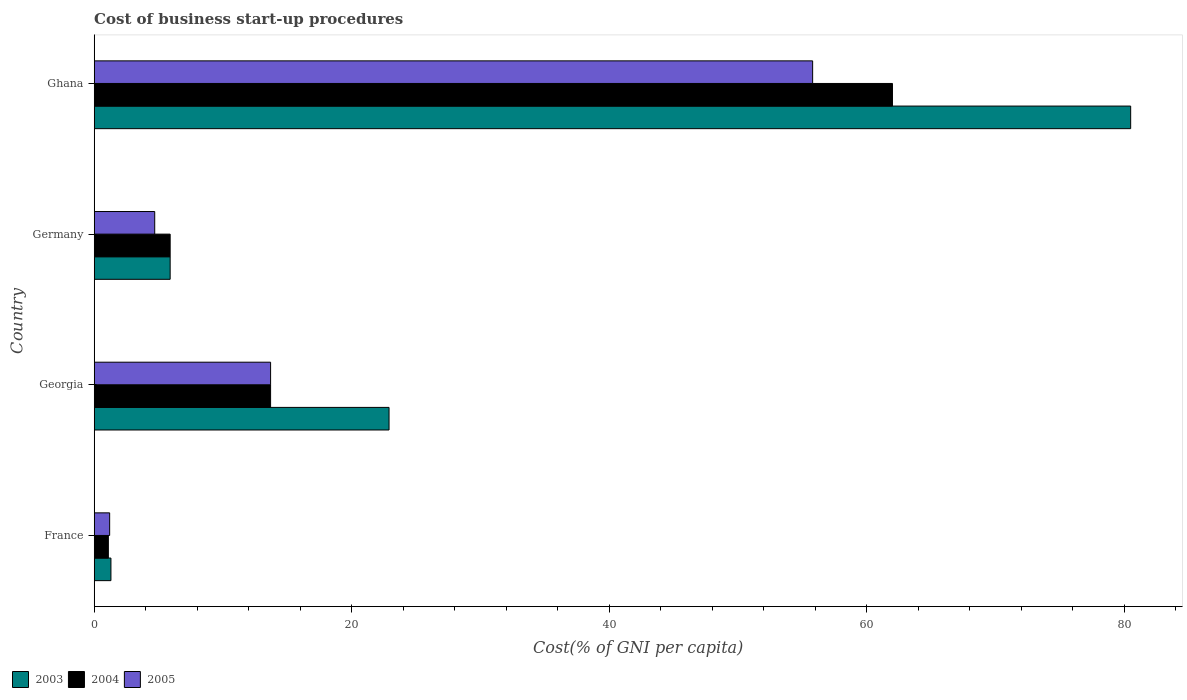How many different coloured bars are there?
Provide a short and direct response. 3. How many bars are there on the 4th tick from the bottom?
Keep it short and to the point. 3. What is the cost of business start-up procedures in 2004 in Ghana?
Ensure brevity in your answer.  62. Across all countries, what is the minimum cost of business start-up procedures in 2004?
Your answer should be very brief. 1.1. In which country was the cost of business start-up procedures in 2003 minimum?
Your answer should be compact. France. What is the total cost of business start-up procedures in 2004 in the graph?
Keep it short and to the point. 82.7. What is the difference between the cost of business start-up procedures in 2003 in Germany and that in Ghana?
Offer a very short reply. -74.6. What is the difference between the cost of business start-up procedures in 2003 in Ghana and the cost of business start-up procedures in 2004 in Georgia?
Offer a very short reply. 66.8. What is the average cost of business start-up procedures in 2004 per country?
Your answer should be compact. 20.68. What is the difference between the cost of business start-up procedures in 2003 and cost of business start-up procedures in 2004 in France?
Your answer should be very brief. 0.2. What is the ratio of the cost of business start-up procedures in 2005 in Germany to that in Ghana?
Ensure brevity in your answer.  0.08. Is the cost of business start-up procedures in 2003 in Georgia less than that in Ghana?
Your answer should be very brief. Yes. Is the difference between the cost of business start-up procedures in 2003 in Georgia and Germany greater than the difference between the cost of business start-up procedures in 2004 in Georgia and Germany?
Offer a very short reply. Yes. What is the difference between the highest and the second highest cost of business start-up procedures in 2003?
Your response must be concise. 57.6. What is the difference between the highest and the lowest cost of business start-up procedures in 2004?
Provide a short and direct response. 60.9. Is the sum of the cost of business start-up procedures in 2005 in France and Georgia greater than the maximum cost of business start-up procedures in 2003 across all countries?
Offer a terse response. No. What does the 3rd bar from the top in Ghana represents?
Your response must be concise. 2003. What does the 2nd bar from the bottom in France represents?
Your response must be concise. 2004. How many bars are there?
Offer a very short reply. 12. Are all the bars in the graph horizontal?
Ensure brevity in your answer.  Yes. Are the values on the major ticks of X-axis written in scientific E-notation?
Keep it short and to the point. No. Where does the legend appear in the graph?
Provide a short and direct response. Bottom left. What is the title of the graph?
Your answer should be very brief. Cost of business start-up procedures. Does "1981" appear as one of the legend labels in the graph?
Provide a short and direct response. No. What is the label or title of the X-axis?
Ensure brevity in your answer.  Cost(% of GNI per capita). What is the Cost(% of GNI per capita) of 2004 in France?
Keep it short and to the point. 1.1. What is the Cost(% of GNI per capita) of 2003 in Georgia?
Offer a terse response. 22.9. What is the Cost(% of GNI per capita) of 2005 in Georgia?
Keep it short and to the point. 13.7. What is the Cost(% of GNI per capita) of 2003 in Germany?
Ensure brevity in your answer.  5.9. What is the Cost(% of GNI per capita) in 2005 in Germany?
Provide a succinct answer. 4.7. What is the Cost(% of GNI per capita) of 2003 in Ghana?
Give a very brief answer. 80.5. What is the Cost(% of GNI per capita) of 2005 in Ghana?
Keep it short and to the point. 55.8. Across all countries, what is the maximum Cost(% of GNI per capita) of 2003?
Your answer should be very brief. 80.5. Across all countries, what is the maximum Cost(% of GNI per capita) in 2005?
Provide a succinct answer. 55.8. Across all countries, what is the minimum Cost(% of GNI per capita) of 2003?
Your answer should be very brief. 1.3. Across all countries, what is the minimum Cost(% of GNI per capita) in 2004?
Make the answer very short. 1.1. Across all countries, what is the minimum Cost(% of GNI per capita) of 2005?
Keep it short and to the point. 1.2. What is the total Cost(% of GNI per capita) of 2003 in the graph?
Provide a succinct answer. 110.6. What is the total Cost(% of GNI per capita) of 2004 in the graph?
Provide a succinct answer. 82.7. What is the total Cost(% of GNI per capita) of 2005 in the graph?
Your response must be concise. 75.4. What is the difference between the Cost(% of GNI per capita) in 2003 in France and that in Georgia?
Your answer should be very brief. -21.6. What is the difference between the Cost(% of GNI per capita) of 2004 in France and that in Georgia?
Keep it short and to the point. -12.6. What is the difference between the Cost(% of GNI per capita) of 2005 in France and that in Germany?
Offer a very short reply. -3.5. What is the difference between the Cost(% of GNI per capita) in 2003 in France and that in Ghana?
Provide a short and direct response. -79.2. What is the difference between the Cost(% of GNI per capita) in 2004 in France and that in Ghana?
Keep it short and to the point. -60.9. What is the difference between the Cost(% of GNI per capita) of 2005 in France and that in Ghana?
Provide a short and direct response. -54.6. What is the difference between the Cost(% of GNI per capita) in 2003 in Georgia and that in Germany?
Offer a terse response. 17. What is the difference between the Cost(% of GNI per capita) of 2005 in Georgia and that in Germany?
Give a very brief answer. 9. What is the difference between the Cost(% of GNI per capita) in 2003 in Georgia and that in Ghana?
Make the answer very short. -57.6. What is the difference between the Cost(% of GNI per capita) of 2004 in Georgia and that in Ghana?
Ensure brevity in your answer.  -48.3. What is the difference between the Cost(% of GNI per capita) in 2005 in Georgia and that in Ghana?
Offer a very short reply. -42.1. What is the difference between the Cost(% of GNI per capita) of 2003 in Germany and that in Ghana?
Your answer should be compact. -74.6. What is the difference between the Cost(% of GNI per capita) in 2004 in Germany and that in Ghana?
Offer a terse response. -56.1. What is the difference between the Cost(% of GNI per capita) of 2005 in Germany and that in Ghana?
Make the answer very short. -51.1. What is the difference between the Cost(% of GNI per capita) in 2003 in France and the Cost(% of GNI per capita) in 2004 in Georgia?
Ensure brevity in your answer.  -12.4. What is the difference between the Cost(% of GNI per capita) of 2004 in France and the Cost(% of GNI per capita) of 2005 in Georgia?
Ensure brevity in your answer.  -12.6. What is the difference between the Cost(% of GNI per capita) of 2003 in France and the Cost(% of GNI per capita) of 2004 in Germany?
Make the answer very short. -4.6. What is the difference between the Cost(% of GNI per capita) of 2004 in France and the Cost(% of GNI per capita) of 2005 in Germany?
Your answer should be compact. -3.6. What is the difference between the Cost(% of GNI per capita) of 2003 in France and the Cost(% of GNI per capita) of 2004 in Ghana?
Your response must be concise. -60.7. What is the difference between the Cost(% of GNI per capita) in 2003 in France and the Cost(% of GNI per capita) in 2005 in Ghana?
Keep it short and to the point. -54.5. What is the difference between the Cost(% of GNI per capita) of 2004 in France and the Cost(% of GNI per capita) of 2005 in Ghana?
Your answer should be compact. -54.7. What is the difference between the Cost(% of GNI per capita) of 2003 in Georgia and the Cost(% of GNI per capita) of 2004 in Germany?
Make the answer very short. 17. What is the difference between the Cost(% of GNI per capita) of 2003 in Georgia and the Cost(% of GNI per capita) of 2005 in Germany?
Make the answer very short. 18.2. What is the difference between the Cost(% of GNI per capita) in 2003 in Georgia and the Cost(% of GNI per capita) in 2004 in Ghana?
Provide a succinct answer. -39.1. What is the difference between the Cost(% of GNI per capita) in 2003 in Georgia and the Cost(% of GNI per capita) in 2005 in Ghana?
Make the answer very short. -32.9. What is the difference between the Cost(% of GNI per capita) in 2004 in Georgia and the Cost(% of GNI per capita) in 2005 in Ghana?
Make the answer very short. -42.1. What is the difference between the Cost(% of GNI per capita) in 2003 in Germany and the Cost(% of GNI per capita) in 2004 in Ghana?
Your answer should be very brief. -56.1. What is the difference between the Cost(% of GNI per capita) of 2003 in Germany and the Cost(% of GNI per capita) of 2005 in Ghana?
Provide a short and direct response. -49.9. What is the difference between the Cost(% of GNI per capita) in 2004 in Germany and the Cost(% of GNI per capita) in 2005 in Ghana?
Your response must be concise. -49.9. What is the average Cost(% of GNI per capita) in 2003 per country?
Ensure brevity in your answer.  27.65. What is the average Cost(% of GNI per capita) in 2004 per country?
Your answer should be very brief. 20.68. What is the average Cost(% of GNI per capita) in 2005 per country?
Provide a short and direct response. 18.85. What is the difference between the Cost(% of GNI per capita) of 2003 and Cost(% of GNI per capita) of 2004 in France?
Provide a short and direct response. 0.2. What is the difference between the Cost(% of GNI per capita) in 2003 and Cost(% of GNI per capita) in 2005 in France?
Keep it short and to the point. 0.1. What is the difference between the Cost(% of GNI per capita) in 2004 and Cost(% of GNI per capita) in 2005 in France?
Your answer should be very brief. -0.1. What is the difference between the Cost(% of GNI per capita) of 2004 and Cost(% of GNI per capita) of 2005 in Germany?
Make the answer very short. 1.2. What is the difference between the Cost(% of GNI per capita) in 2003 and Cost(% of GNI per capita) in 2005 in Ghana?
Keep it short and to the point. 24.7. What is the ratio of the Cost(% of GNI per capita) of 2003 in France to that in Georgia?
Your answer should be very brief. 0.06. What is the ratio of the Cost(% of GNI per capita) of 2004 in France to that in Georgia?
Offer a terse response. 0.08. What is the ratio of the Cost(% of GNI per capita) of 2005 in France to that in Georgia?
Keep it short and to the point. 0.09. What is the ratio of the Cost(% of GNI per capita) in 2003 in France to that in Germany?
Keep it short and to the point. 0.22. What is the ratio of the Cost(% of GNI per capita) in 2004 in France to that in Germany?
Give a very brief answer. 0.19. What is the ratio of the Cost(% of GNI per capita) of 2005 in France to that in Germany?
Your response must be concise. 0.26. What is the ratio of the Cost(% of GNI per capita) of 2003 in France to that in Ghana?
Give a very brief answer. 0.02. What is the ratio of the Cost(% of GNI per capita) of 2004 in France to that in Ghana?
Ensure brevity in your answer.  0.02. What is the ratio of the Cost(% of GNI per capita) of 2005 in France to that in Ghana?
Your response must be concise. 0.02. What is the ratio of the Cost(% of GNI per capita) in 2003 in Georgia to that in Germany?
Make the answer very short. 3.88. What is the ratio of the Cost(% of GNI per capita) in 2004 in Georgia to that in Germany?
Provide a short and direct response. 2.32. What is the ratio of the Cost(% of GNI per capita) of 2005 in Georgia to that in Germany?
Offer a very short reply. 2.91. What is the ratio of the Cost(% of GNI per capita) in 2003 in Georgia to that in Ghana?
Give a very brief answer. 0.28. What is the ratio of the Cost(% of GNI per capita) in 2004 in Georgia to that in Ghana?
Give a very brief answer. 0.22. What is the ratio of the Cost(% of GNI per capita) of 2005 in Georgia to that in Ghana?
Your answer should be very brief. 0.25. What is the ratio of the Cost(% of GNI per capita) of 2003 in Germany to that in Ghana?
Give a very brief answer. 0.07. What is the ratio of the Cost(% of GNI per capita) of 2004 in Germany to that in Ghana?
Provide a succinct answer. 0.1. What is the ratio of the Cost(% of GNI per capita) in 2005 in Germany to that in Ghana?
Your answer should be very brief. 0.08. What is the difference between the highest and the second highest Cost(% of GNI per capita) of 2003?
Offer a terse response. 57.6. What is the difference between the highest and the second highest Cost(% of GNI per capita) in 2004?
Provide a succinct answer. 48.3. What is the difference between the highest and the second highest Cost(% of GNI per capita) of 2005?
Your answer should be very brief. 42.1. What is the difference between the highest and the lowest Cost(% of GNI per capita) of 2003?
Make the answer very short. 79.2. What is the difference between the highest and the lowest Cost(% of GNI per capita) of 2004?
Provide a short and direct response. 60.9. What is the difference between the highest and the lowest Cost(% of GNI per capita) of 2005?
Your answer should be very brief. 54.6. 